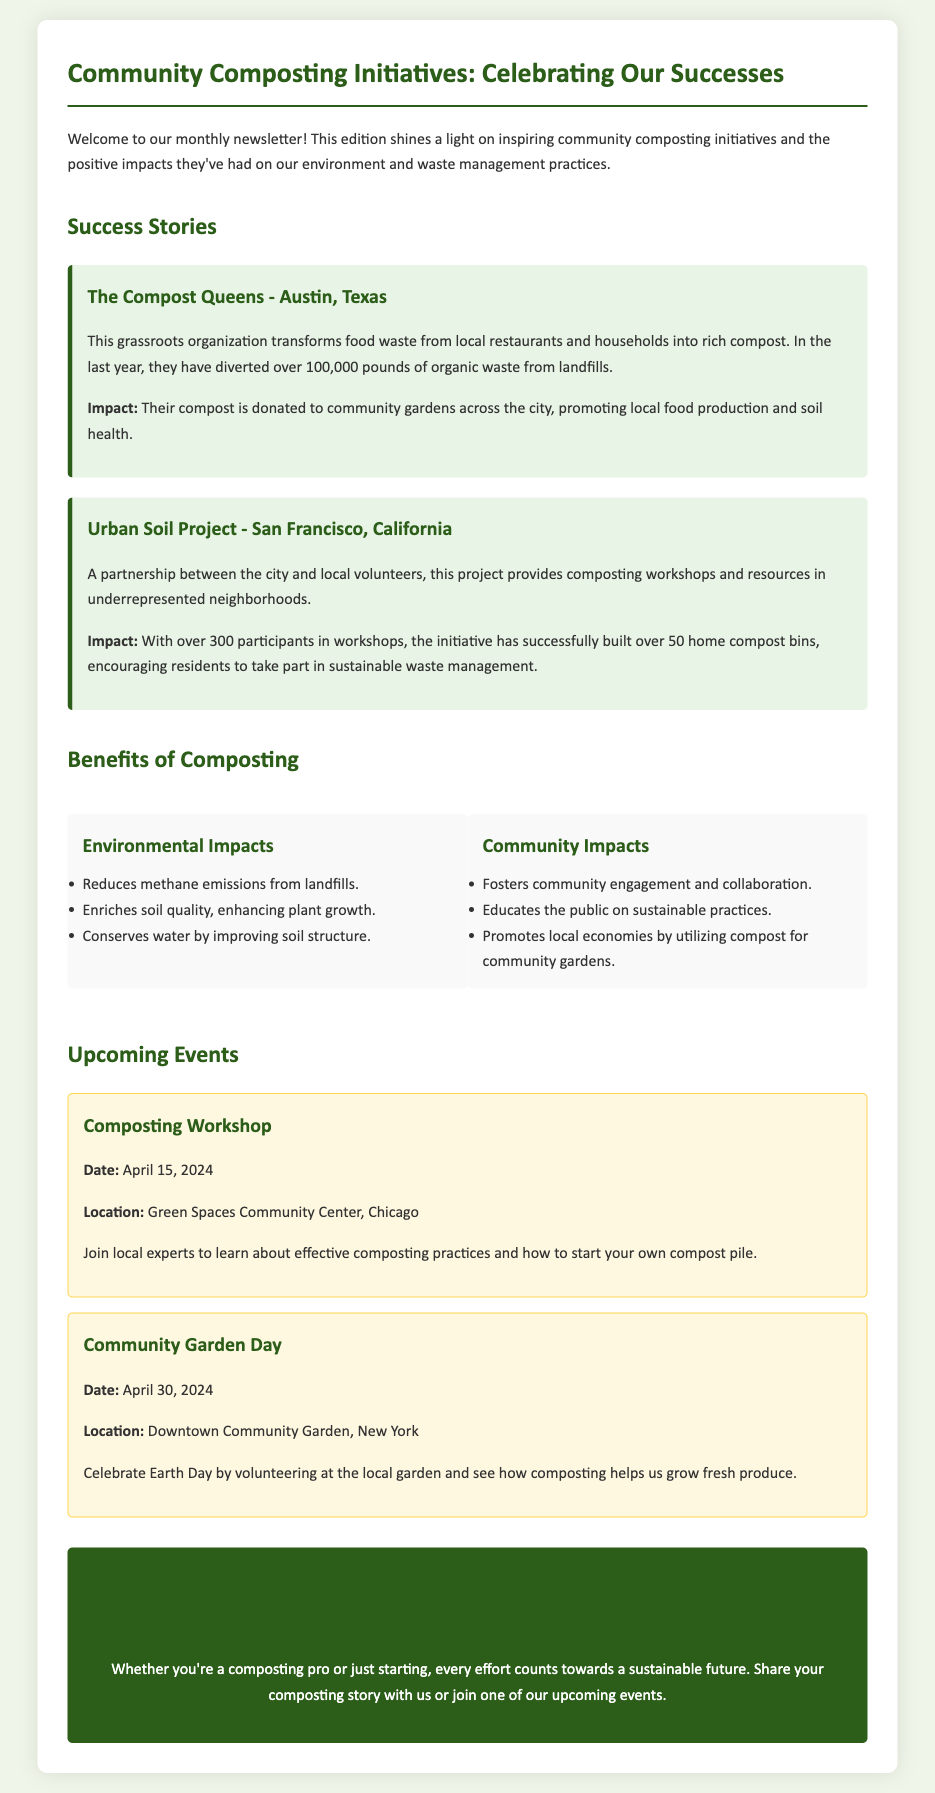what is the title of the newsletter? The title is prominently displayed at the top of the document as "Community Composting Initiatives: Celebrating Our Successes."
Answer: Community Composting Initiatives: Celebrating Our Successes how many pounds of organic waste have The Compost Queens diverted? The document states that The Compost Queens have diverted over 100,000 pounds of organic waste from landfills.
Answer: 100,000 pounds what is the date of the Composting Workshop? The date for the Composting Workshop is clearly mentioned in the upcoming events section.
Answer: April 15, 2024 which city is home to the Urban Soil Project? The document specifies that the Urban Soil Project is located in San Francisco, California.
Answer: San Francisco, California how many home compost bins have been built through the Urban Soil Project? The document mentions that over 50 home compost bins have been successfully built by this project.
Answer: 50 what are the two main types of impacts listed under the benefits of composting? The benefits section of the newsletter divides impacts into environmental and community impacts.
Answer: Environmental and Community what is one way that The Compost Queens contribute to community engagement? The document highlights that their compost is donated to community gardens, promoting local food production and soil health.
Answer: Donated to community gardens what is the location of the Community Garden Day event? The location of the event is explicitly mentioned in the upcoming events section.
Answer: Downtown Community Garden, New York who is invited to share their composting stories? The newsletter invites anyone interested in composting, whether experienced or just starting, to share their stories.
Answer: Everyone 